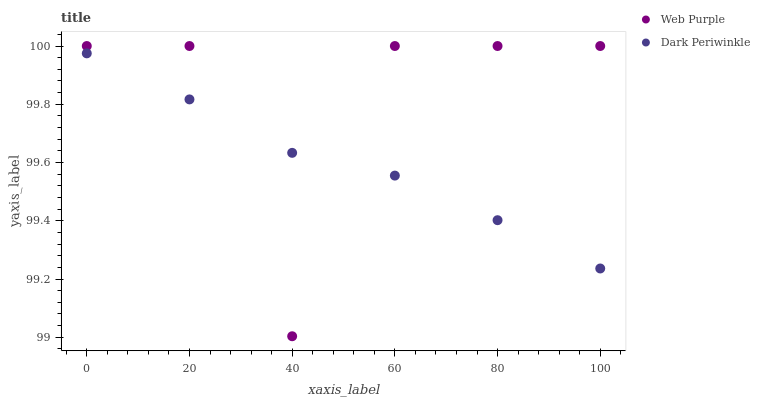Does Dark Periwinkle have the minimum area under the curve?
Answer yes or no. Yes. Does Web Purple have the maximum area under the curve?
Answer yes or no. Yes. Does Dark Periwinkle have the maximum area under the curve?
Answer yes or no. No. Is Dark Periwinkle the smoothest?
Answer yes or no. Yes. Is Web Purple the roughest?
Answer yes or no. Yes. Is Dark Periwinkle the roughest?
Answer yes or no. No. Does Web Purple have the lowest value?
Answer yes or no. Yes. Does Dark Periwinkle have the lowest value?
Answer yes or no. No. Does Web Purple have the highest value?
Answer yes or no. Yes. Does Dark Periwinkle have the highest value?
Answer yes or no. No. Does Dark Periwinkle intersect Web Purple?
Answer yes or no. Yes. Is Dark Periwinkle less than Web Purple?
Answer yes or no. No. Is Dark Periwinkle greater than Web Purple?
Answer yes or no. No. 